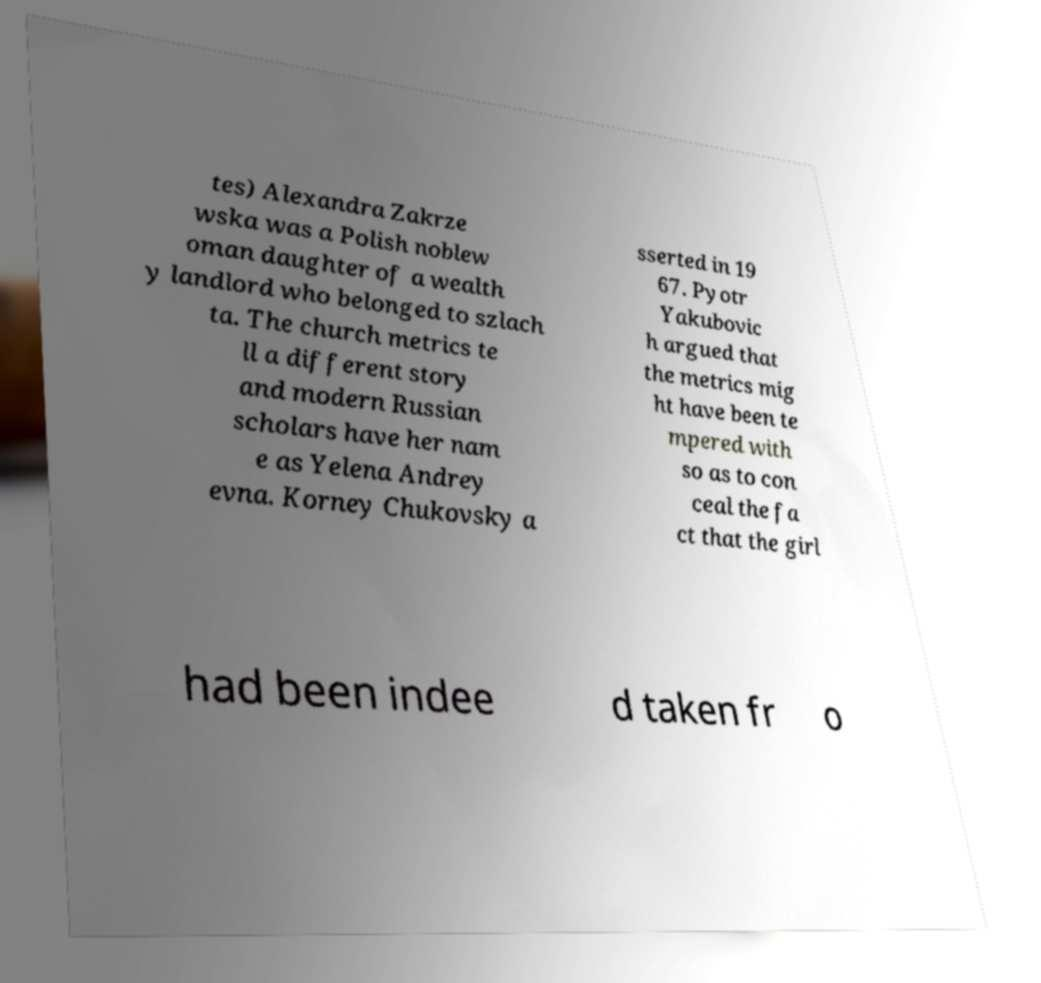Can you accurately transcribe the text from the provided image for me? tes) Alexandra Zakrze wska was a Polish noblew oman daughter of a wealth y landlord who belonged to szlach ta. The church metrics te ll a different story and modern Russian scholars have her nam e as Yelena Andrey evna. Korney Chukovsky a sserted in 19 67. Pyotr Yakubovic h argued that the metrics mig ht have been te mpered with so as to con ceal the fa ct that the girl had been indee d taken fr o 